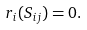Convert formula to latex. <formula><loc_0><loc_0><loc_500><loc_500>r _ { i } ( S _ { i j } ) = 0 .</formula> 